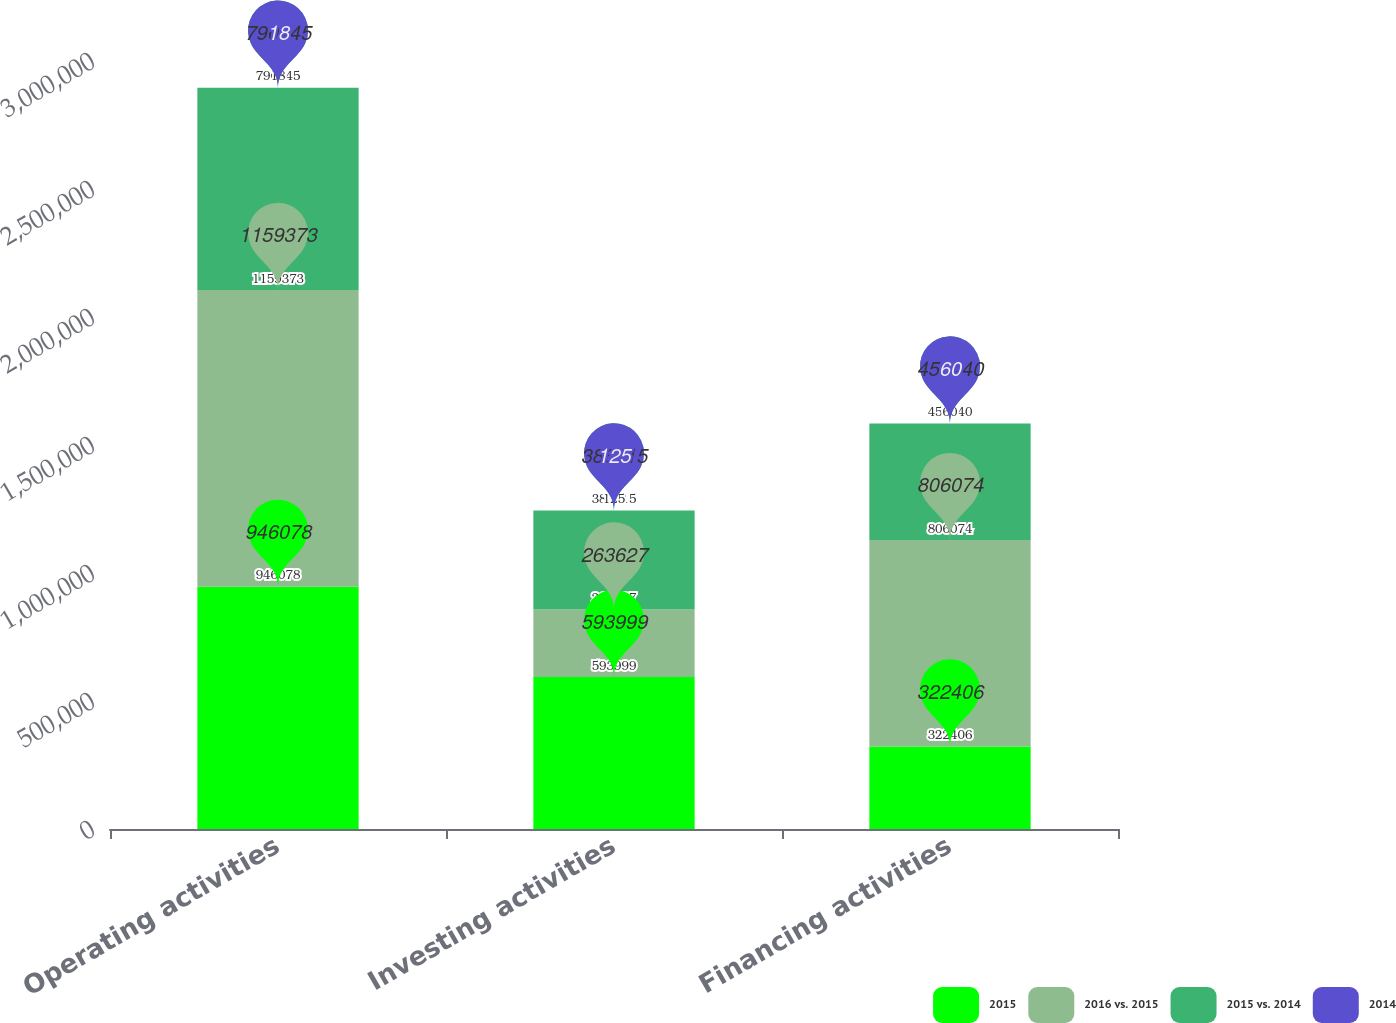Convert chart to OTSL. <chart><loc_0><loc_0><loc_500><loc_500><stacked_bar_chart><ecel><fcel>Operating activities<fcel>Investing activities<fcel>Financing activities<nl><fcel>2015<fcel>946078<fcel>593999<fcel>322406<nl><fcel>2016 vs. 2015<fcel>1.15937e+06<fcel>263627<fcel>806074<nl><fcel>2015 vs. 2014<fcel>790145<fcel>386715<fcel>455440<nl><fcel>2014<fcel>18<fcel>125<fcel>60<nl></chart> 